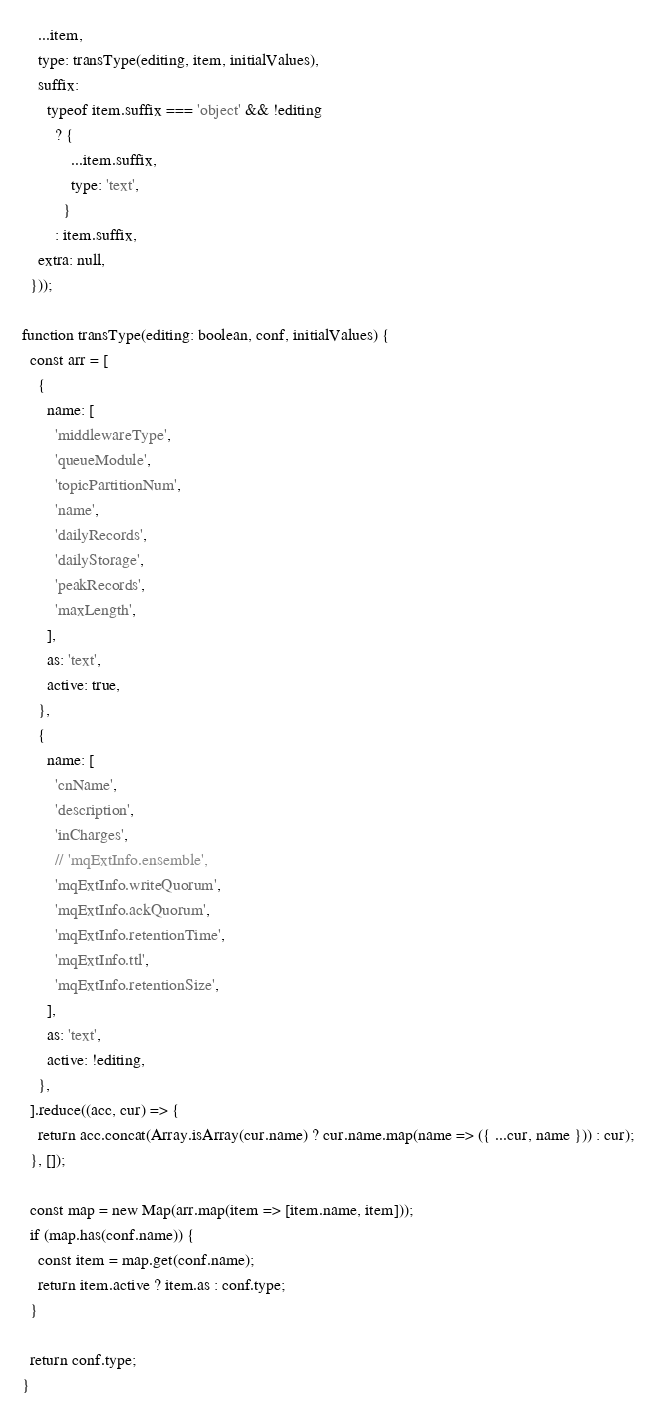<code> <loc_0><loc_0><loc_500><loc_500><_TypeScript_>    ...item,
    type: transType(editing, item, initialValues),
    suffix:
      typeof item.suffix === 'object' && !editing
        ? {
            ...item.suffix,
            type: 'text',
          }
        : item.suffix,
    extra: null,
  }));

function transType(editing: boolean, conf, initialValues) {
  const arr = [
    {
      name: [
        'middlewareType',
        'queueModule',
        'topicPartitionNum',
        'name',
        'dailyRecords',
        'dailyStorage',
        'peakRecords',
        'maxLength',
      ],
      as: 'text',
      active: true,
    },
    {
      name: [
        'cnName',
        'description',
        'inCharges',
        // 'mqExtInfo.ensemble',
        'mqExtInfo.writeQuorum',
        'mqExtInfo.ackQuorum',
        'mqExtInfo.retentionTime',
        'mqExtInfo.ttl',
        'mqExtInfo.retentionSize',
      ],
      as: 'text',
      active: !editing,
    },
  ].reduce((acc, cur) => {
    return acc.concat(Array.isArray(cur.name) ? cur.name.map(name => ({ ...cur, name })) : cur);
  }, []);

  const map = new Map(arr.map(item => [item.name, item]));
  if (map.has(conf.name)) {
    const item = map.get(conf.name);
    return item.active ? item.as : conf.type;
  }

  return conf.type;
}
</code> 